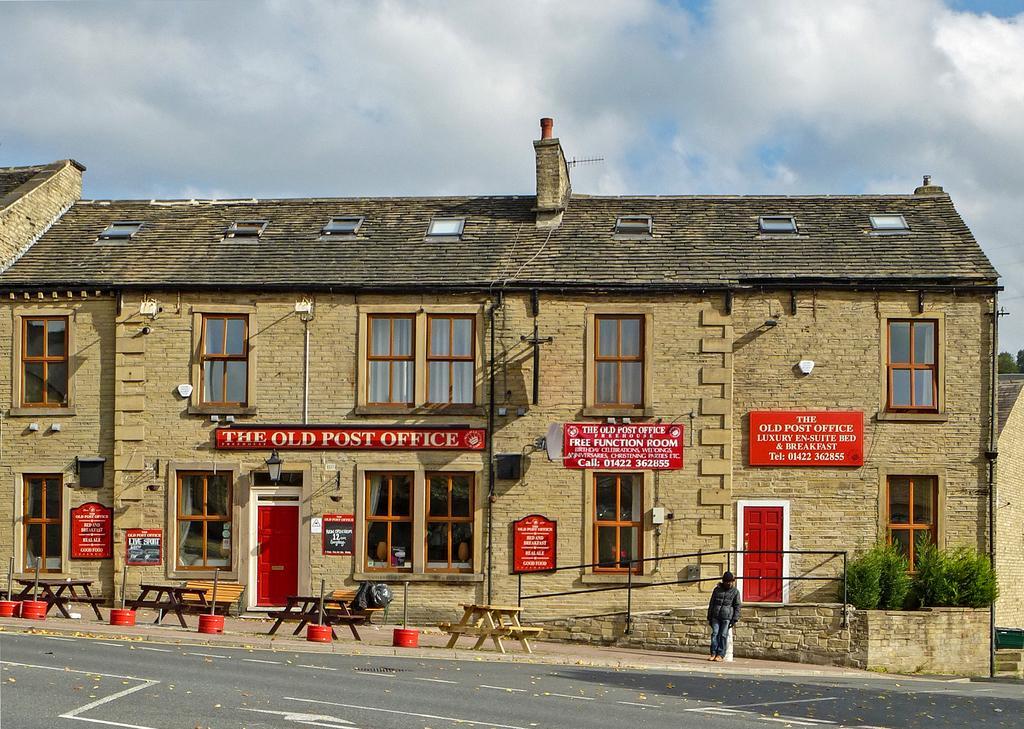Can you describe this image briefly? In this picture we can see a building, roof, windows, boards on the wall, a poster on the wall, doors, benches, poles, plants and a person is standing and wearing a jacket, cap. At the bottom of the image we can see the road and dry leaves. At the top of the image we can see the clouds in the sky. 